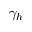<formula> <loc_0><loc_0><loc_500><loc_500>\gamma _ { h }</formula> 